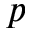Convert formula to latex. <formula><loc_0><loc_0><loc_500><loc_500>p</formula> 